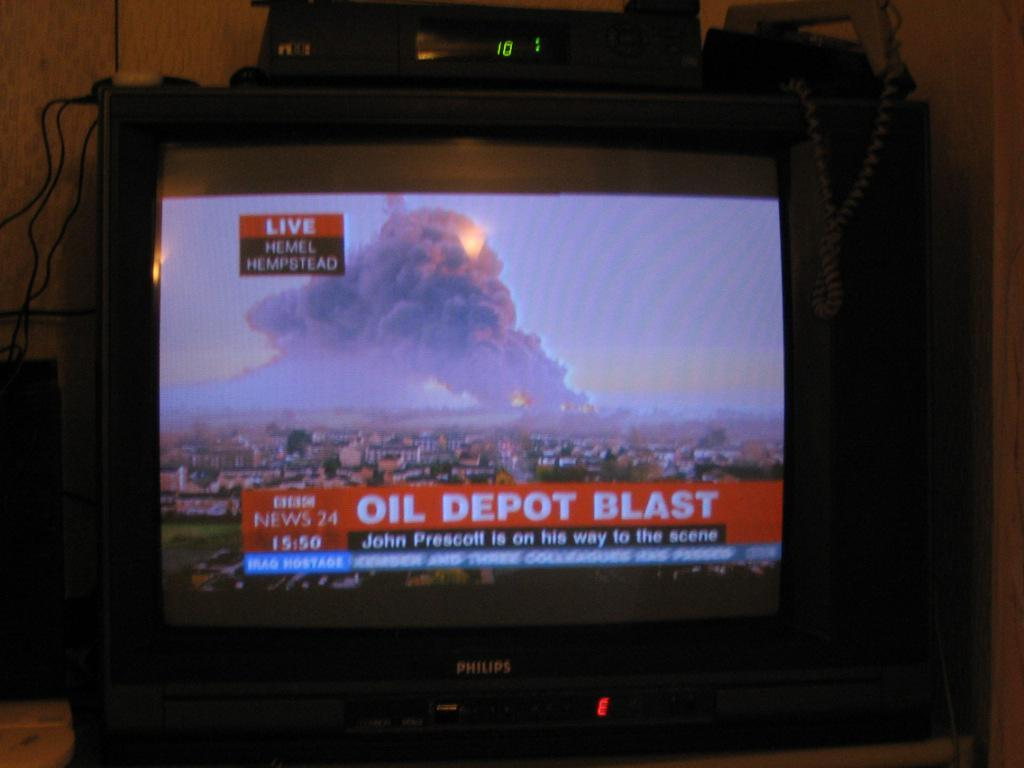<image>
Share a concise interpretation of the image provided. Television news screen that is live from Hemel Hempstead that says Oil Depot Blast. 